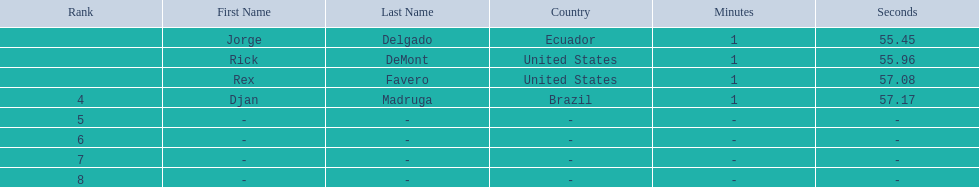What is the time for each name 1:55.45, 1:55.96, 1:57.08, 1:57.17. 